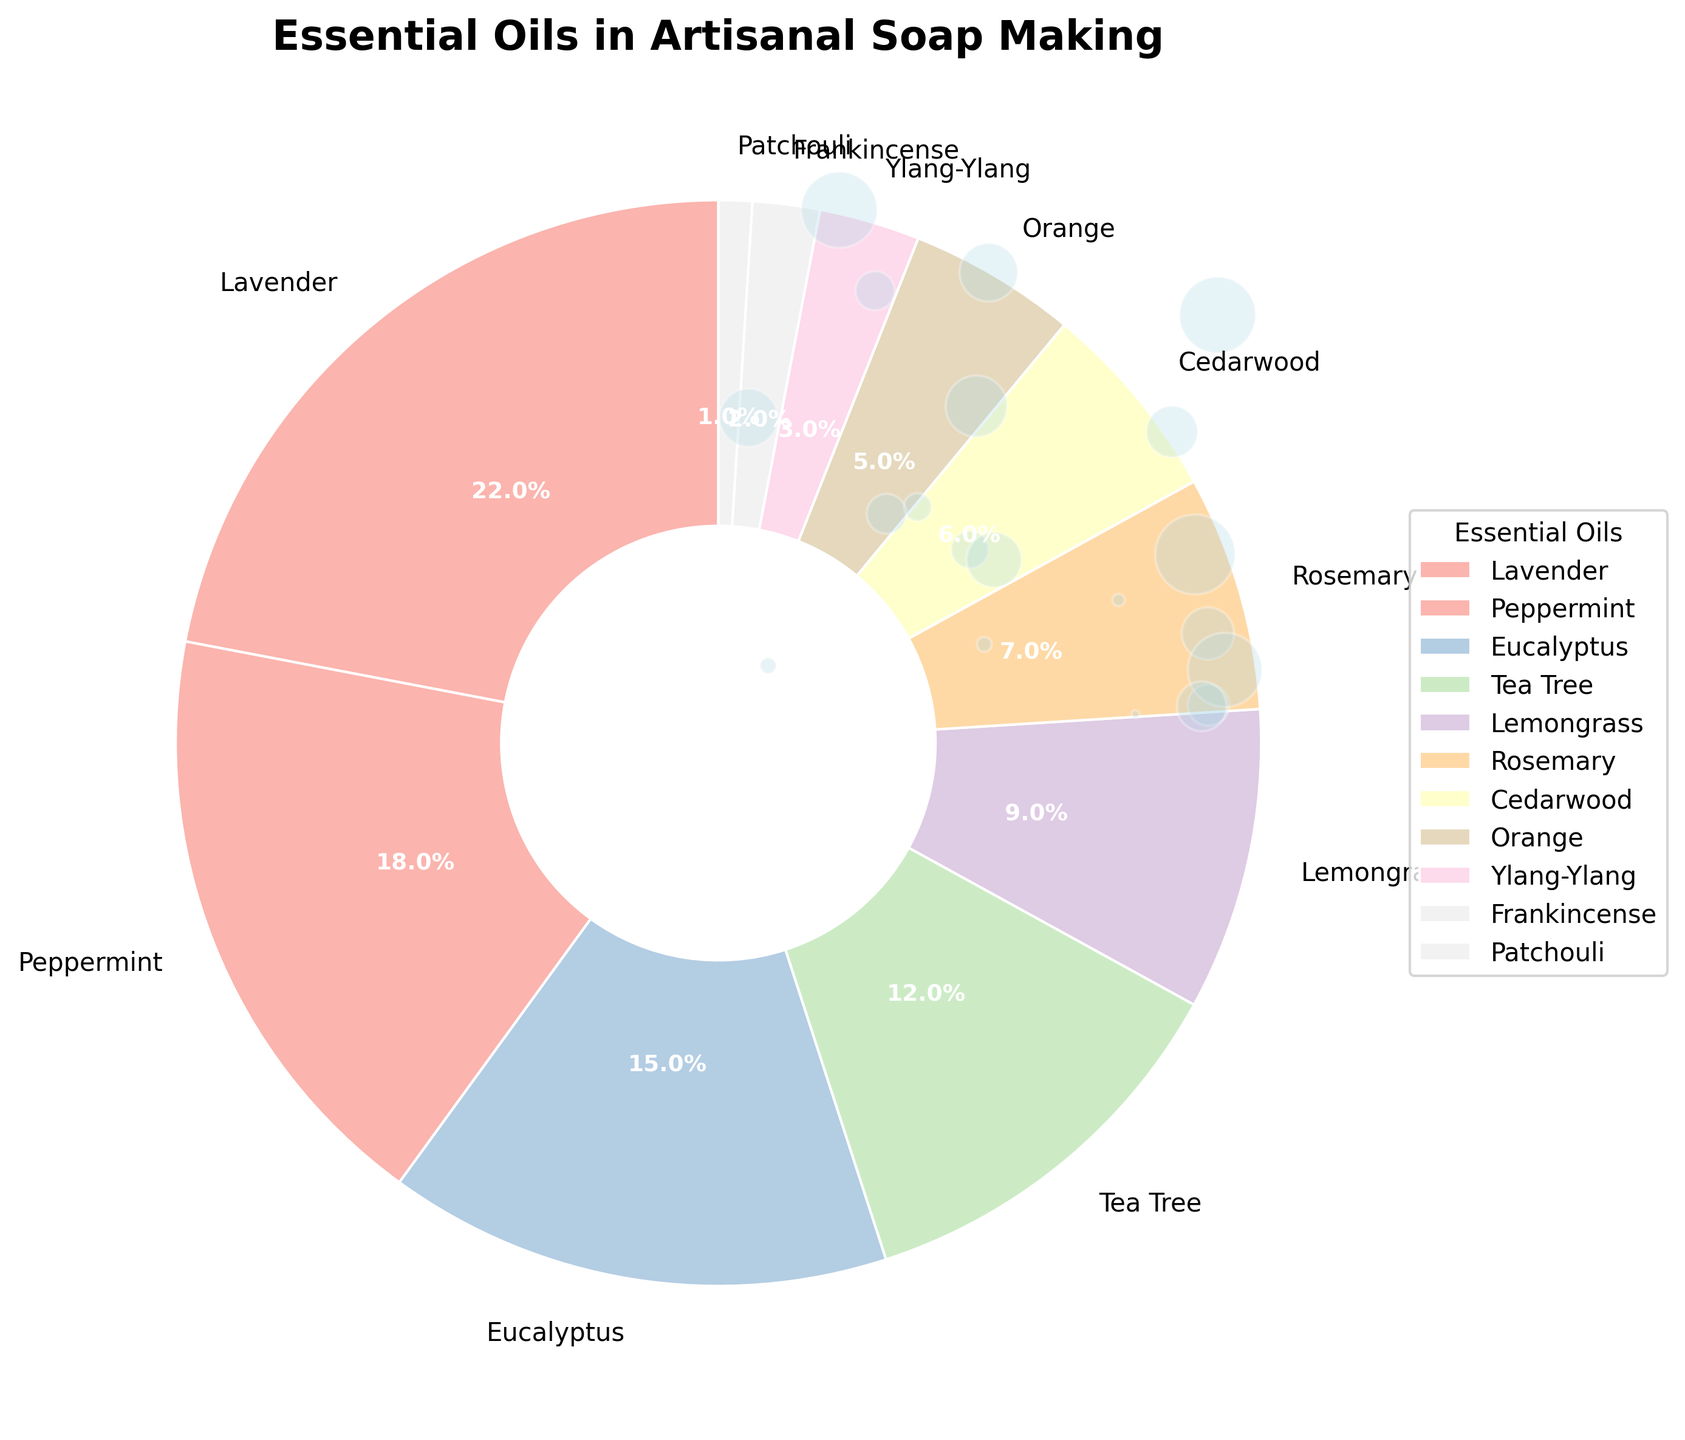What is the most used essential oil in artisanal soap making? By observing the pie chart, the wedge representing Lavender is the largest, indicating it is the most used essential oil.
Answer: Lavender Which essential oil is used less, Ylang-Ylang or Frankincense? The pie chart shows that Ylang-Ylang has a larger wedge than Frankincense, indicating Ylang-Ylang is used more than Frankincense.
Answer: Frankincense What is the combined percentage of Eucalyptus and Tea Tree oils? From the figure, Eucalyptus is 15% and Tea Tree is 12%. The combined percentage is 15% + 12% = 27%.
Answer: 27% Are Peppermint and Lemongrass used in equal amounts? The pie chart reveals that the wedge for Peppermint is larger than that for Lemongrass. Peppermint is 18% and Lemongrass is 9%, so they are not used in equal amounts.
Answer: No How much more is Lavender used compared to Cedarwood? The pie chart shows Lavender is 22% and Cedarwood is 6%. The difference is 22% - 6% = 16%.
Answer: 16% Which essential oil has the third highest usage? By observing the size of the wedges, Lavender is first (22%), followed by Peppermint (18%), and then Eucalyptus (15%) is the third highest.
Answer: Eucalyptus What is the total percentage of essential oils used less than 5%? The pie chart shows Orange (5%), Ylang-Ylang (3%), Frankincense (2%), Patchouli (1%). Adding these gives: 5% + 3% + 2% + 1% = 11%.
Answer: 11% Are there more essential oils used in amounts greater than 10% or less than 10%? The wedge segments show Lavender (22%), Peppermint (18%), Eucalyptus (15%), and Tea Tree (12%) are greater than 10%. Lemongrass (9%), Rosemary (7%), Cedarwood (6%), Orange (5%), Ylang-Ylang (3%), Frankincense (2%), Patchouli (1%) are less than 10%. There are 4 greater than 10% and 7 less than 10%.
Answer: Less Which essential oil has the smallest usage? The pie chart shows Patchouli has the smallest wedge, indicating it is used the least, at 1%.
Answer: Patchouli 